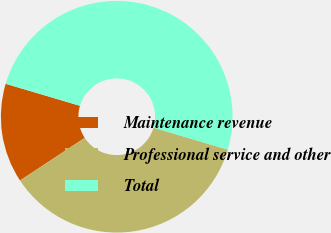<chart> <loc_0><loc_0><loc_500><loc_500><pie_chart><fcel>Maintenance revenue<fcel>Professional service and other<fcel>Total<nl><fcel>13.87%<fcel>36.13%<fcel>50.0%<nl></chart> 